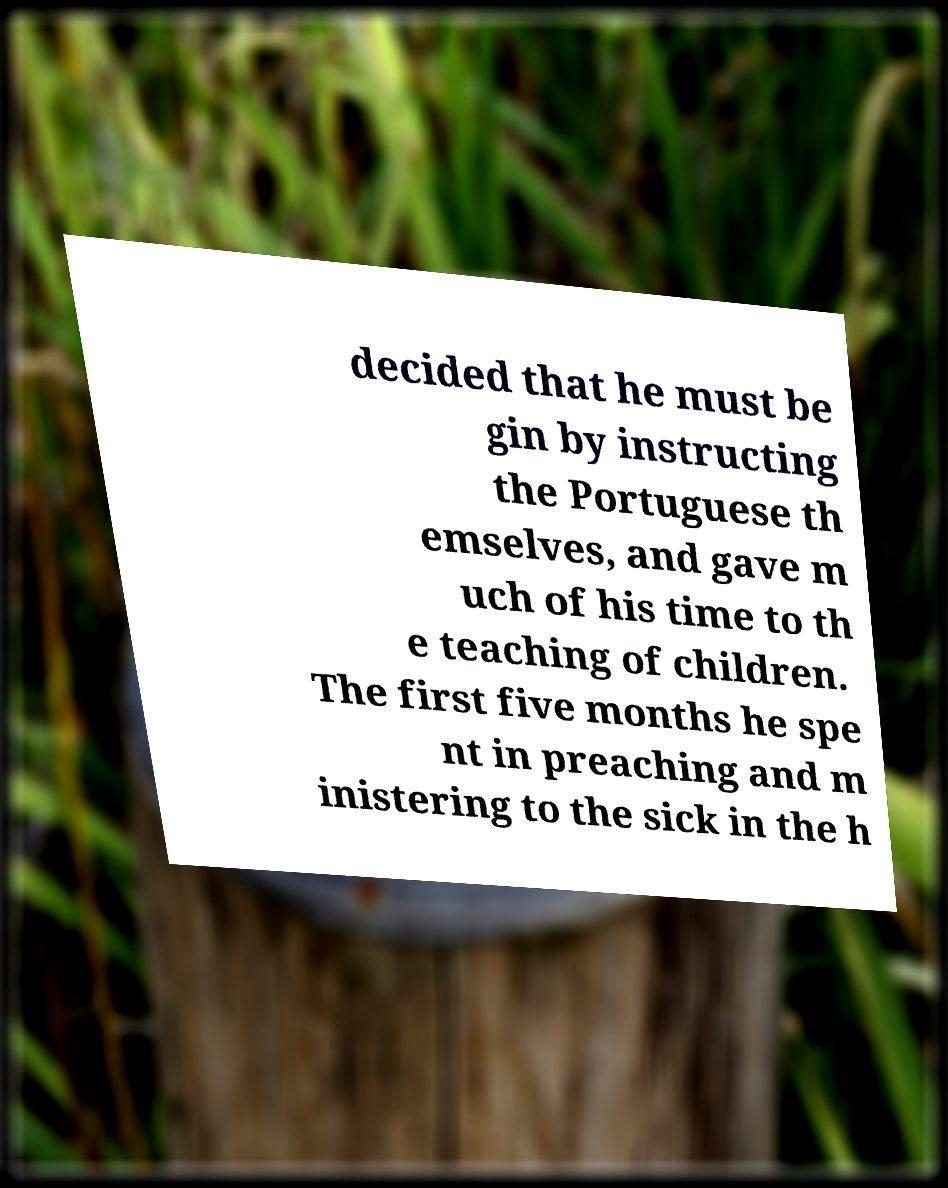Please read and relay the text visible in this image. What does it say? decided that he must be gin by instructing the Portuguese th emselves, and gave m uch of his time to th e teaching of children. The first five months he spe nt in preaching and m inistering to the sick in the h 